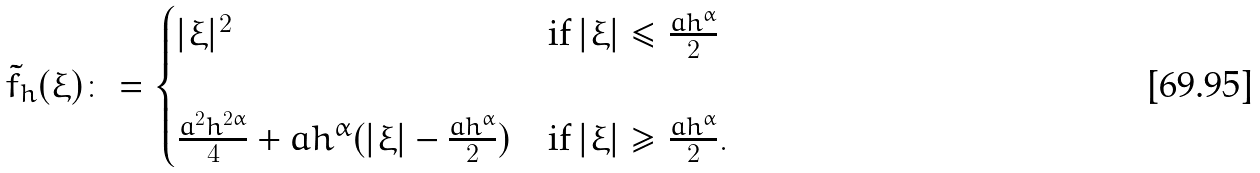<formula> <loc_0><loc_0><loc_500><loc_500>\tilde { f } _ { h } ( \xi ) \colon = \begin{cases} | \xi | ^ { 2 } & \text {if } | \xi | \leq \frac { a h ^ { \alpha } } { 2 } \\ \\ \frac { a ^ { 2 } h ^ { 2 \alpha } } { 4 } + a h ^ { \alpha } ( | \xi | - \frac { a h ^ { \alpha } } { 2 } ) & \text {if } | \xi | \geq \frac { a h ^ { \alpha } } { 2 } . \end{cases}</formula> 